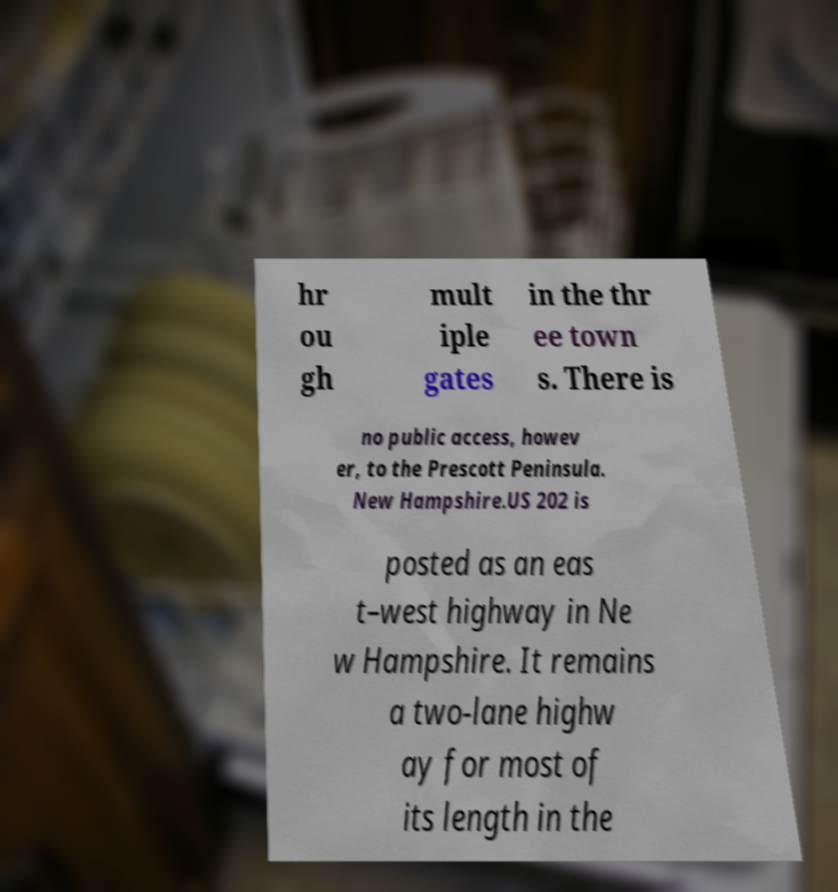Can you read and provide the text displayed in the image?This photo seems to have some interesting text. Can you extract and type it out for me? hr ou gh mult iple gates in the thr ee town s. There is no public access, howev er, to the Prescott Peninsula. New Hampshire.US 202 is posted as an eas t–west highway in Ne w Hampshire. It remains a two-lane highw ay for most of its length in the 